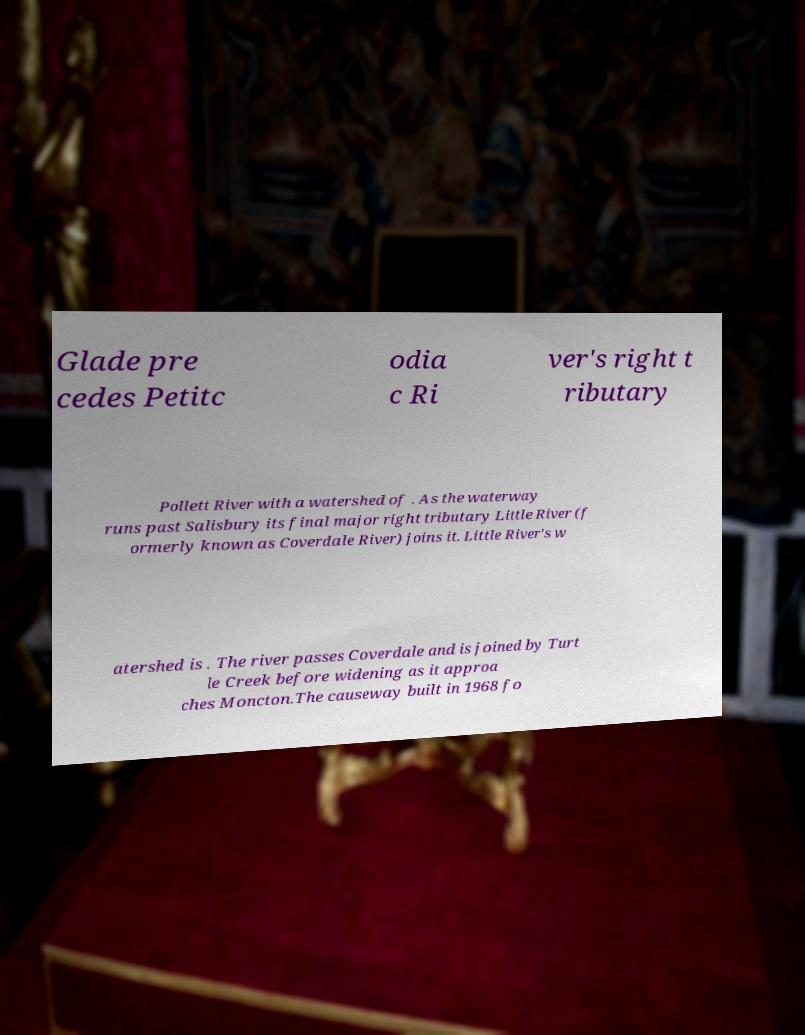Could you extract and type out the text from this image? Glade pre cedes Petitc odia c Ri ver's right t ributary Pollett River with a watershed of . As the waterway runs past Salisbury its final major right tributary Little River (f ormerly known as Coverdale River) joins it. Little River's w atershed is . The river passes Coverdale and is joined by Turt le Creek before widening as it approa ches Moncton.The causeway built in 1968 fo 